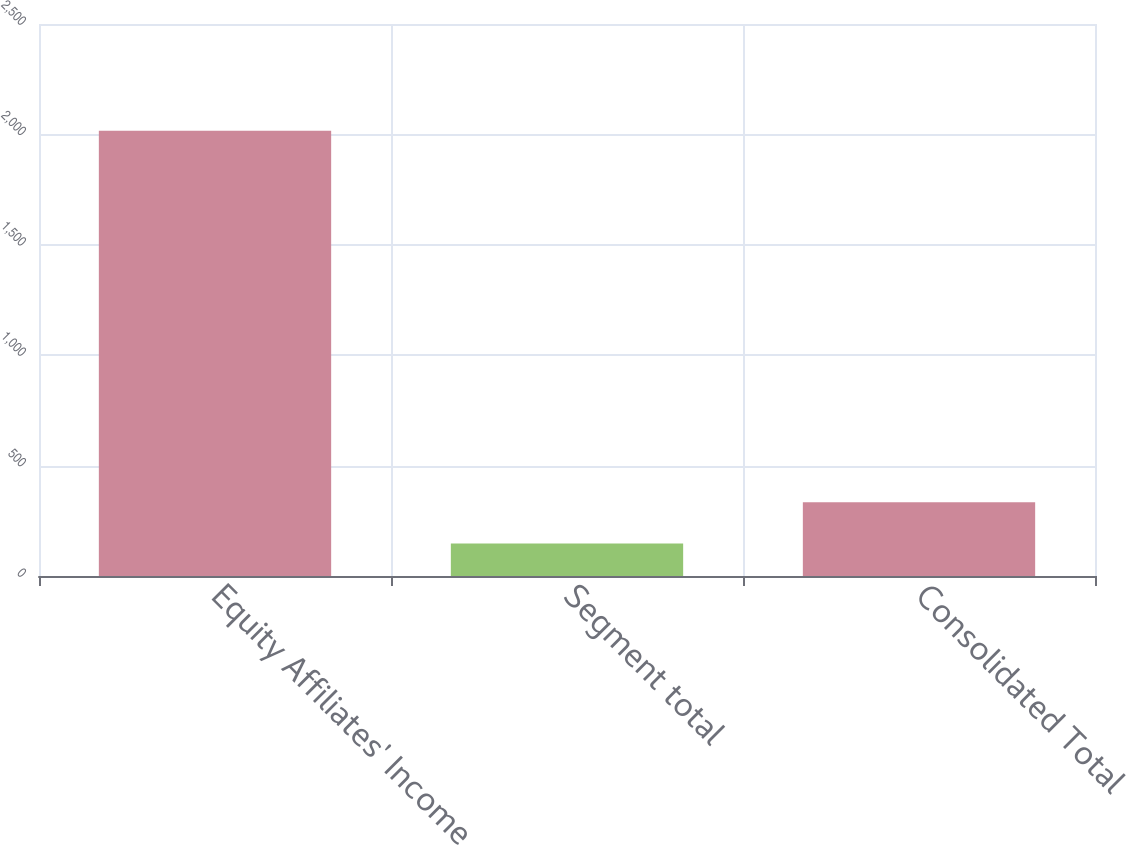Convert chart to OTSL. <chart><loc_0><loc_0><loc_500><loc_500><bar_chart><fcel>Equity Affiliates' Income<fcel>Segment total<fcel>Consolidated Total<nl><fcel>2016<fcel>147<fcel>333.9<nl></chart> 